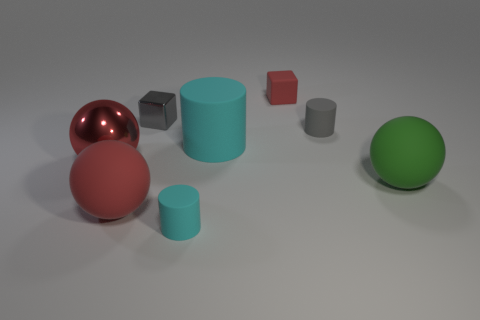There is a thing that is the same color as the large cylinder; what is its size?
Offer a terse response. Small. What is the shape of the rubber object that is the same color as the small metallic thing?
Make the answer very short. Cylinder. The metallic block has what size?
Provide a succinct answer. Small. How many other green rubber things have the same size as the green rubber object?
Offer a terse response. 0. Is the color of the big matte cylinder the same as the metal cube?
Make the answer very short. No. Does the big red sphere behind the green sphere have the same material as the small cylinder that is in front of the large red metal ball?
Give a very brief answer. No. Is the number of cyan metallic cylinders greater than the number of tiny rubber objects?
Your response must be concise. No. Is there anything else that has the same color as the tiny metallic object?
Your response must be concise. Yes. Are the small red block and the large cylinder made of the same material?
Provide a short and direct response. Yes. Is the number of tiny gray shiny objects less than the number of big red things?
Provide a short and direct response. Yes. 